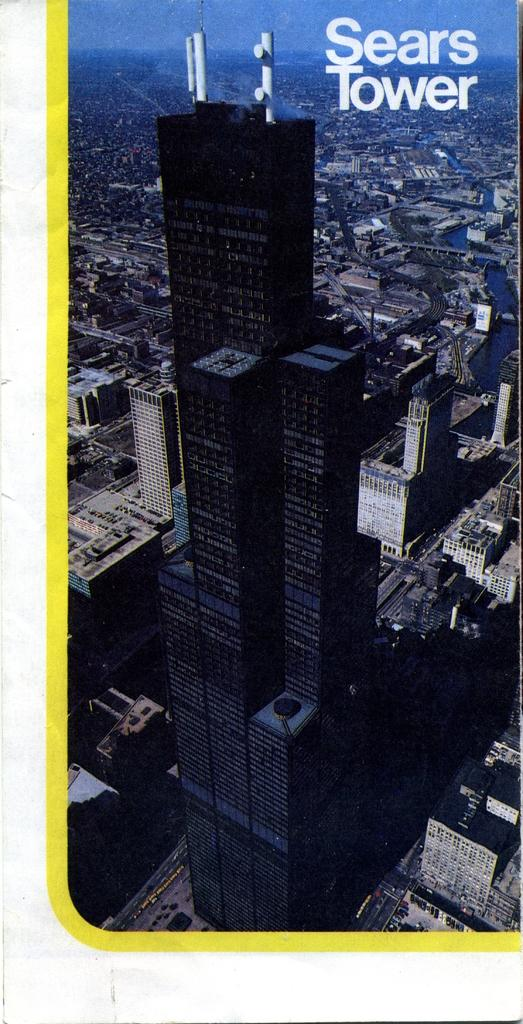What type of structures can be seen in the image? There are buildings in the image. What else can be seen on the ground in the image? There are roads in the image. What is visible in the background of the image? The sky is visible in the image. Is there any additional information about the image itself? Yes, there is a watermark on the image. What type of guitar can be seen hanging on the wall in the image? There is no guitar present in the image; it features buildings, roads, and the sky. 